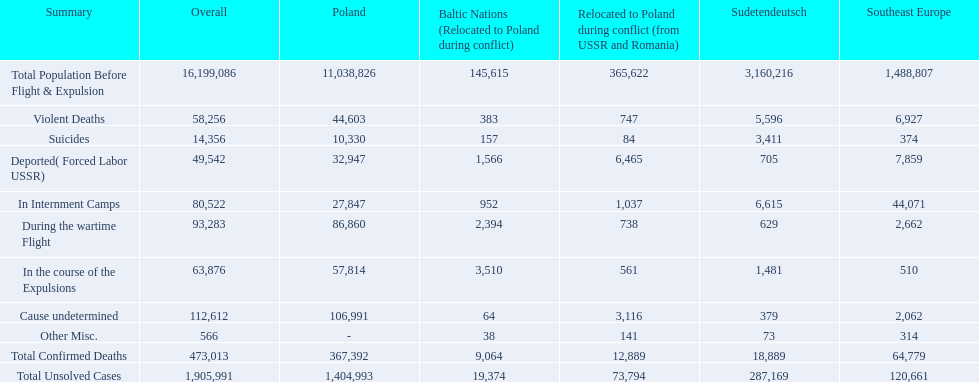What are all of the descriptions? Total Population Before Flight & Expulsion, Violent Deaths, Suicides, Deported( Forced Labor USSR), In Internment Camps, During the wartime Flight, In the course of the Expulsions, Cause undetermined, Other Misc., Total Confirmed Deaths, Total Unsolved Cases. What were their total number of deaths? 16,199,086, 58,256, 14,356, 49,542, 80,522, 93,283, 63,876, 112,612, 566, 473,013, 1,905,991. What about just from violent deaths? 58,256. 